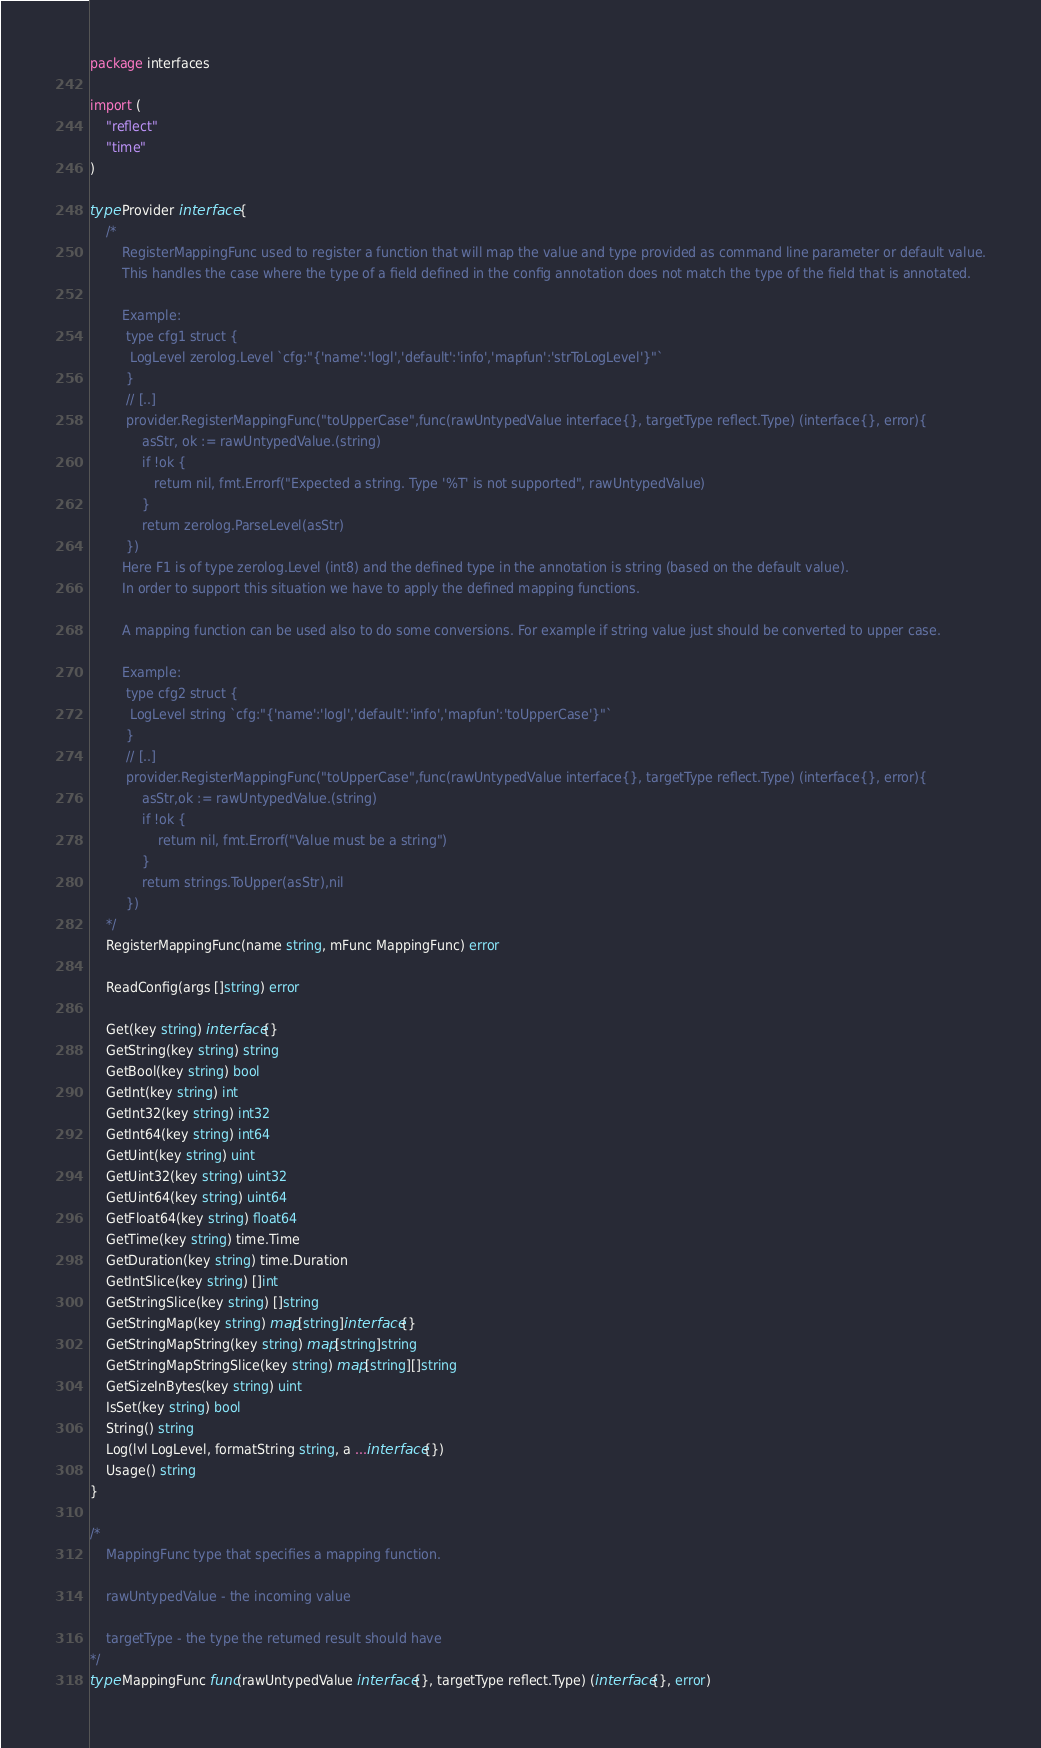Convert code to text. <code><loc_0><loc_0><loc_500><loc_500><_Go_>package interfaces

import (
	"reflect"
	"time"
)

type Provider interface {
	/*
		RegisterMappingFunc used to register a function that will map the value and type provided as command line parameter or default value.
		This handles the case where the type of a field defined in the config annotation does not match the type of the field that is annotated.

		Example:
		 type cfg1 struct {
		  LogLevel zerolog.Level `cfg:"{'name':'logl','default':'info','mapfun':'strToLogLevel'}"`
		 }
		 // [..]
		 provider.RegisterMappingFunc("toUpperCase",func(rawUntypedValue interface{}, targetType reflect.Type) (interface{}, error){
			 asStr, ok := rawUntypedValue.(string)
			 if !ok {
			 	return nil, fmt.Errorf("Expected a string. Type '%T' is not supported", rawUntypedValue)
			 }
			 return zerolog.ParseLevel(asStr)
		 })
		Here F1 is of type zerolog.Level (int8) and the defined type in the annotation is string (based on the default value).
		In order to support this situation we have to apply the defined mapping functions.

		A mapping function can be used also to do some conversions. For example if string value just should be converted to upper case.

		Example:
		 type cfg2 struct {
		  LogLevel string `cfg:"{'name':'logl','default':'info','mapfun':'toUpperCase'}"`
		 }
		 // [..]
		 provider.RegisterMappingFunc("toUpperCase",func(rawUntypedValue interface{}, targetType reflect.Type) (interface{}, error){
			 asStr,ok := rawUntypedValue.(string)
			 if !ok {
				 return nil, fmt.Errorf("Value must be a string")
			 }
			 return strings.ToUpper(asStr),nil
		 })
	*/
	RegisterMappingFunc(name string, mFunc MappingFunc) error

	ReadConfig(args []string) error

	Get(key string) interface{}
	GetString(key string) string
	GetBool(key string) bool
	GetInt(key string) int
	GetInt32(key string) int32
	GetInt64(key string) int64
	GetUint(key string) uint
	GetUint32(key string) uint32
	GetUint64(key string) uint64
	GetFloat64(key string) float64
	GetTime(key string) time.Time
	GetDuration(key string) time.Duration
	GetIntSlice(key string) []int
	GetStringSlice(key string) []string
	GetStringMap(key string) map[string]interface{}
	GetStringMapString(key string) map[string]string
	GetStringMapStringSlice(key string) map[string][]string
	GetSizeInBytes(key string) uint
	IsSet(key string) bool
	String() string
	Log(lvl LogLevel, formatString string, a ...interface{})
	Usage() string
}

/*
	MappingFunc type that specifies a mapping function.

	rawUntypedValue - the incoming value

	targetType - the type the returned result should have
*/
type MappingFunc func(rawUntypedValue interface{}, targetType reflect.Type) (interface{}, error)
</code> 